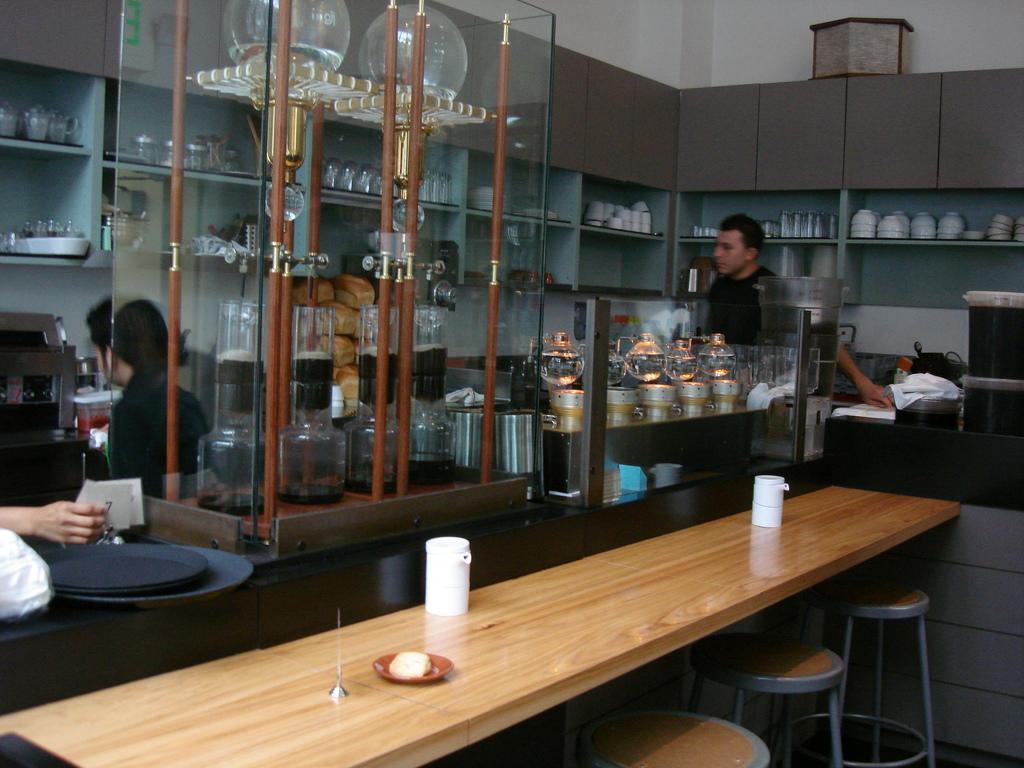Can you describe this image briefly? In this image at the bottom there is a table, on the table there are some objects, under the table, there are some tables, in the middle there are glass jars, ,lights, behind the wall, there is a rack, in the rack there are some bowls, glasses, in front of the rack there are some persons, at the top there is the wall, on the left side there is a person's hand which is holding paper and plates kept on table. 